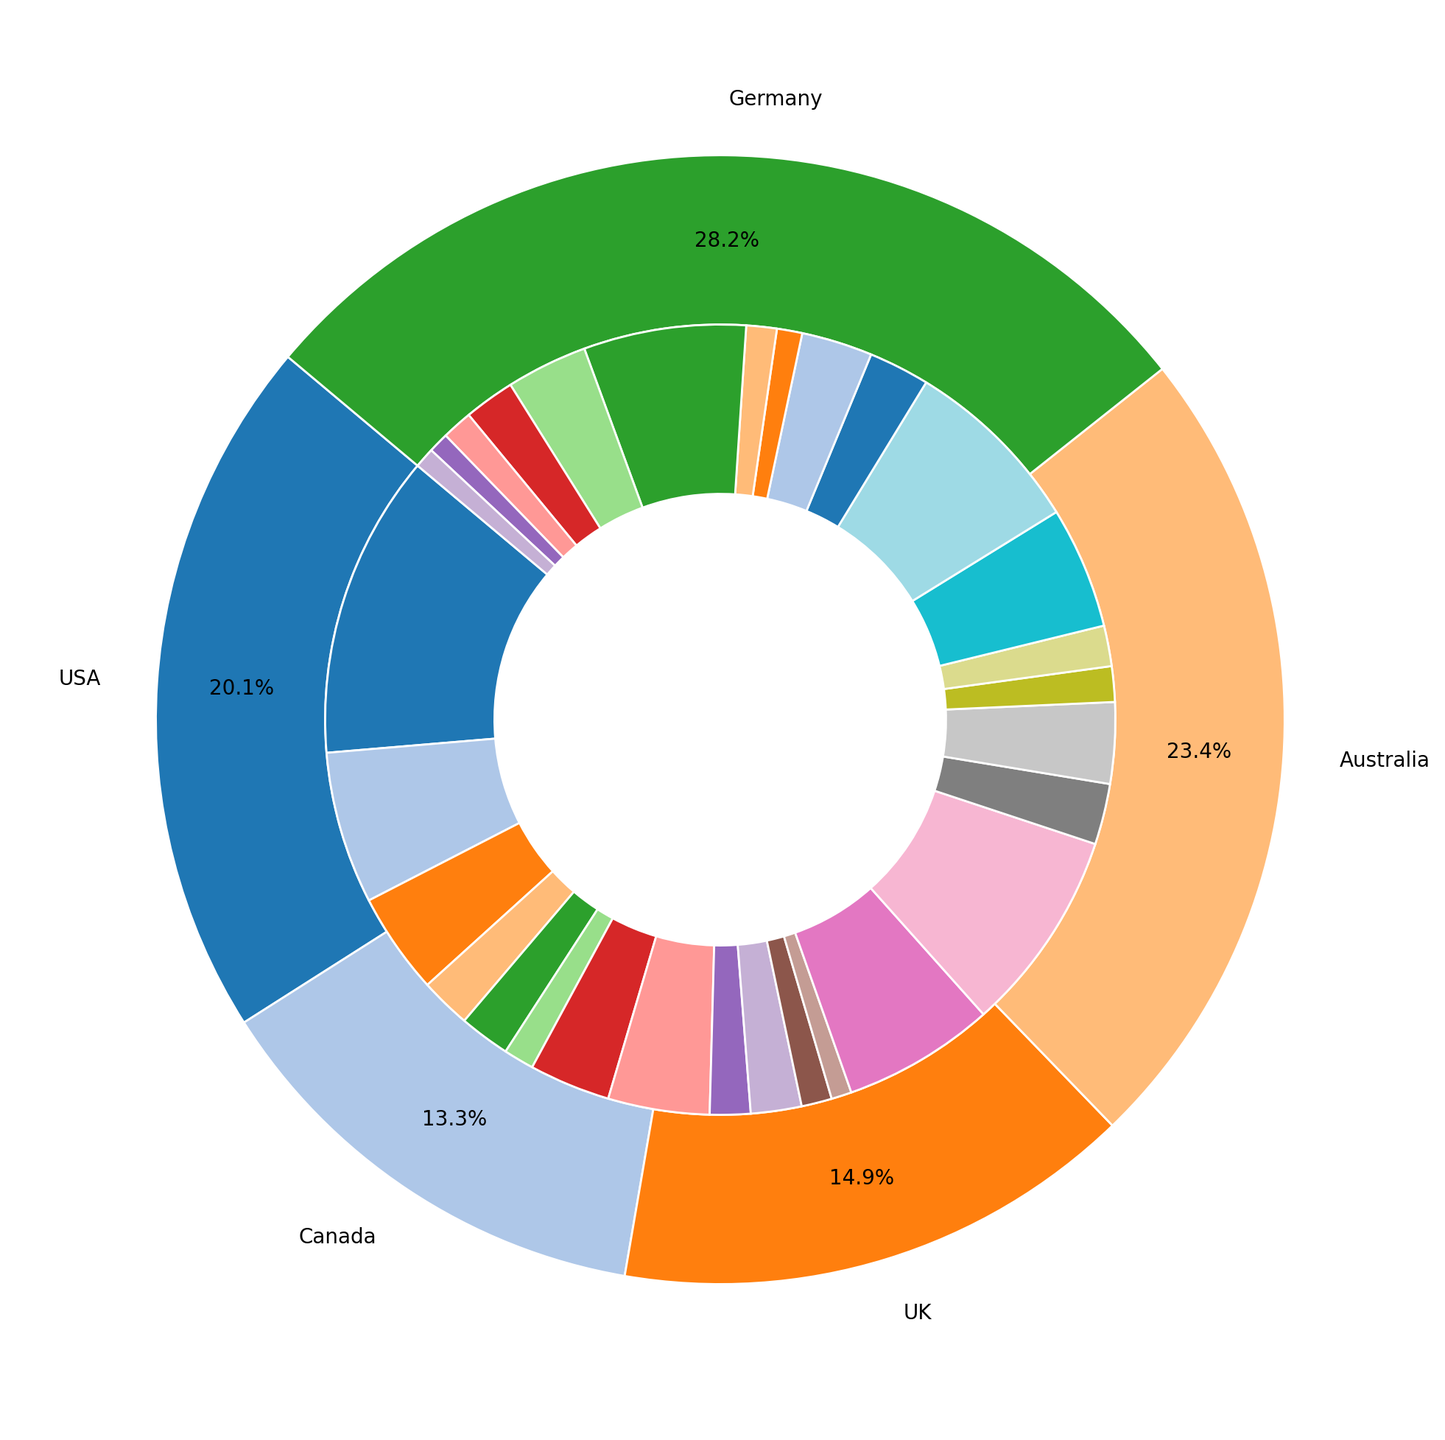What percentage of the total work visas is for the US? The outer ring of the pie chart represents percentages by country. The segment labeled "USA" shows its percentage.
Answer: 32.3% Which sector in Canada has the least number of work visas? The inner ring of the pie chart shows the breakdown by country and sector. For Canada, find the smallest segment in the inner ring among the sectors.
Answer: Education Between Technology and Healthcare sectors in the UK, which one has more work visas? In the inner ring for the UK, compare the segments for Technology and Healthcare sectors by their size.
Answer: Technology How many more work visas are there in the Technology sector in Australia compared to the Education sector? For Australia, sum the work visas for the Technology sector (18000 + 12000 = 30000) and for the Education sector (3000 + 2500 = 5500). Subtract the total for the Education sector from the Technology sector.
Answer: 24500 Which country has the most diverse work visa categories? Review the inner ring segments for each country and count the number of distinct work visa categories in each country.
Answer: USA Is the H1B visa category more common in Technology or Healthcare in the USA? In the inner ring for the USA, compare the segments for H1B visas in the Technology and Healthcare sectors by their size.
Answer: Technology What is the total number of work visas in the Healthcare sector across all countries? Sum the work visas in the Healthcare sector for all countries: USA (10000 + 5000), Canada (5000 + 4000), UK (8000 + 6000), Australia (7000 + 6000), Germany (5000 + 3000).
Answer: 64000 